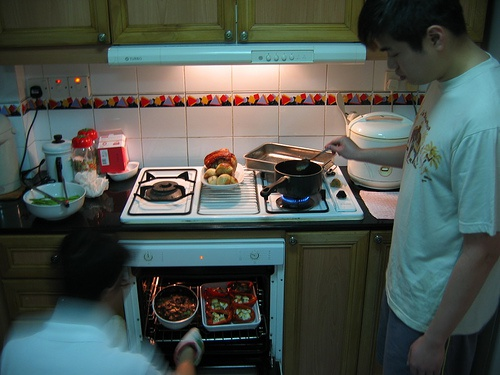Describe the objects in this image and their specific colors. I can see people in black and teal tones, oven in black and teal tones, people in black, teal, and lightblue tones, bowl in black and teal tones, and bowl in black, maroon, purple, and gray tones in this image. 